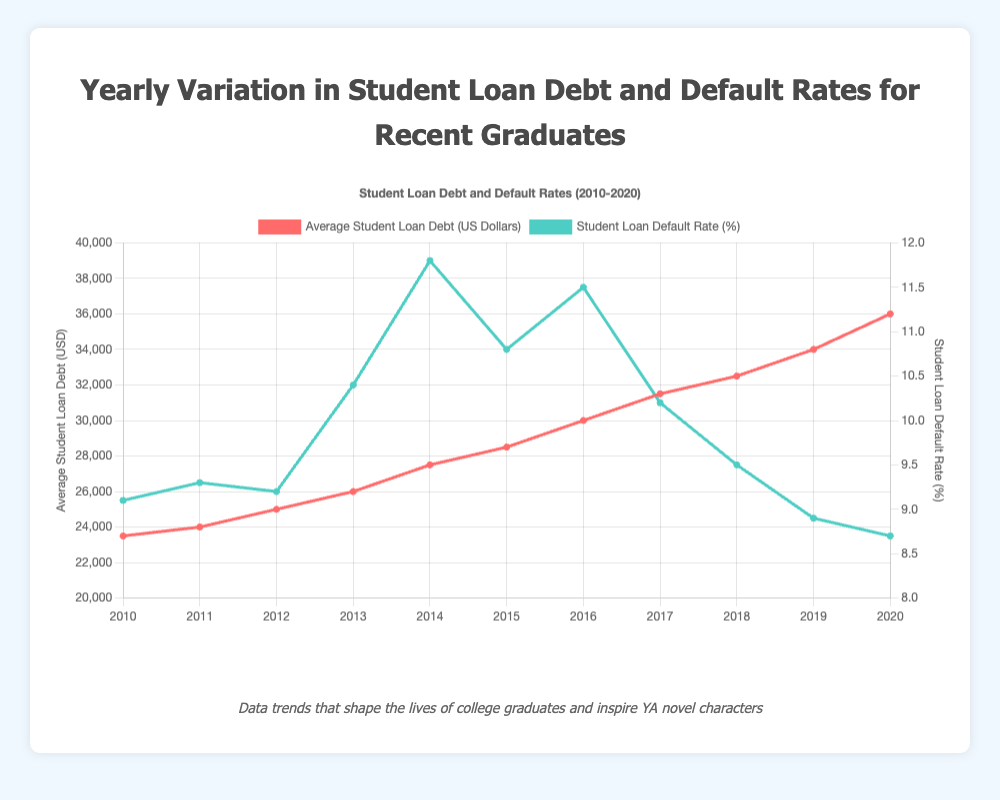what is the trend in average student loan debt from 2010 to 2020? To determine the trend in average student loan debt, observe the line representing student loan debt across the years in the chart. It shows a consistent upward trajectory from $23,500 in 2010 to $36,000 in 2020.
Answer: Increasing which year had the highest default rate? Analyze the line representing the student loan default rate. The peak occurs in 2014 at 11.8%.
Answer: 2014 by how much did the average student loan debt increase from 2010 to 2020? Find the debt values for 2010 and 2020 from the chart. The increase is calculated as $36,000 (2020) - $23,500 (2010).
Answer: $12,500 compare the average student loan debt in 2015 and 2016. Which year had higher debt and by how much? Select the values from 2015 and 2016. The debt in 2015 is $28,500 and in 2016 is $30,000. The difference is $30,000 - $28,500.
Answer: 2016 by $1,500 did the default rate ever decrease for two consecutive years? If so, when? Scan the default rate data for consecutive year decreases. In 2018 and 2019, the rates are 9.5% and 8.9%, respectively, showing a consecutive decrease.
Answer: Yes, 2018 and 2019 what is the lowest default rate recorded and in which year did it occur? Identify the lowest point on the default rate line. The lowest rate is 8.7% in 2020.
Answer: 8.7%, 2020 calculate the average default rate over the entire period. Sum the default rates from 2010 to 2020 and divide by the number of years. (9.1 + 9.3 + 9.2 + 10.4 + 11.8 + 10.8 + 11.5 + 10.2 + 9.5 + 8.9 + 8.7) / 11.
Answer: 9.91% what year experienced the largest increase in average student loan debt compared to the previous year? Examine yearly differences in debt: highest jump is between 2018 ($32,500) and 2019 ($34,000), a change of $1,500.
Answer: 2019 how did the default rate change from 2013 to 2014? Default rate in 2013 was 10.4%, rising to 11.8% in 2014. The change is 11.8% - 10.4%.
Answer: Increased by 1.4% compare the visual attributes of the two lines for their colors. Identify the colors of the lines representing each dataset. The line for debt is red, while the line for the default rate is green.
Answer: Debt: red, Default rate: green 